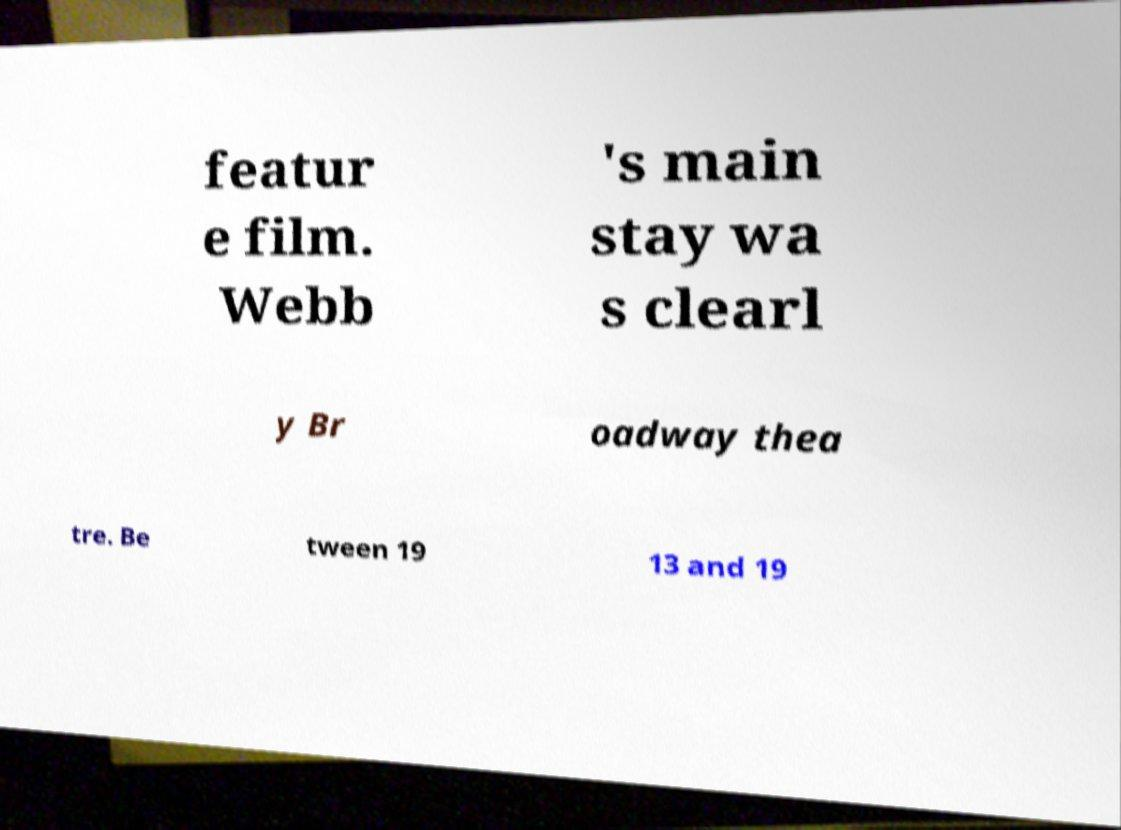What messages or text are displayed in this image? I need them in a readable, typed format. featur e film. Webb 's main stay wa s clearl y Br oadway thea tre. Be tween 19 13 and 19 